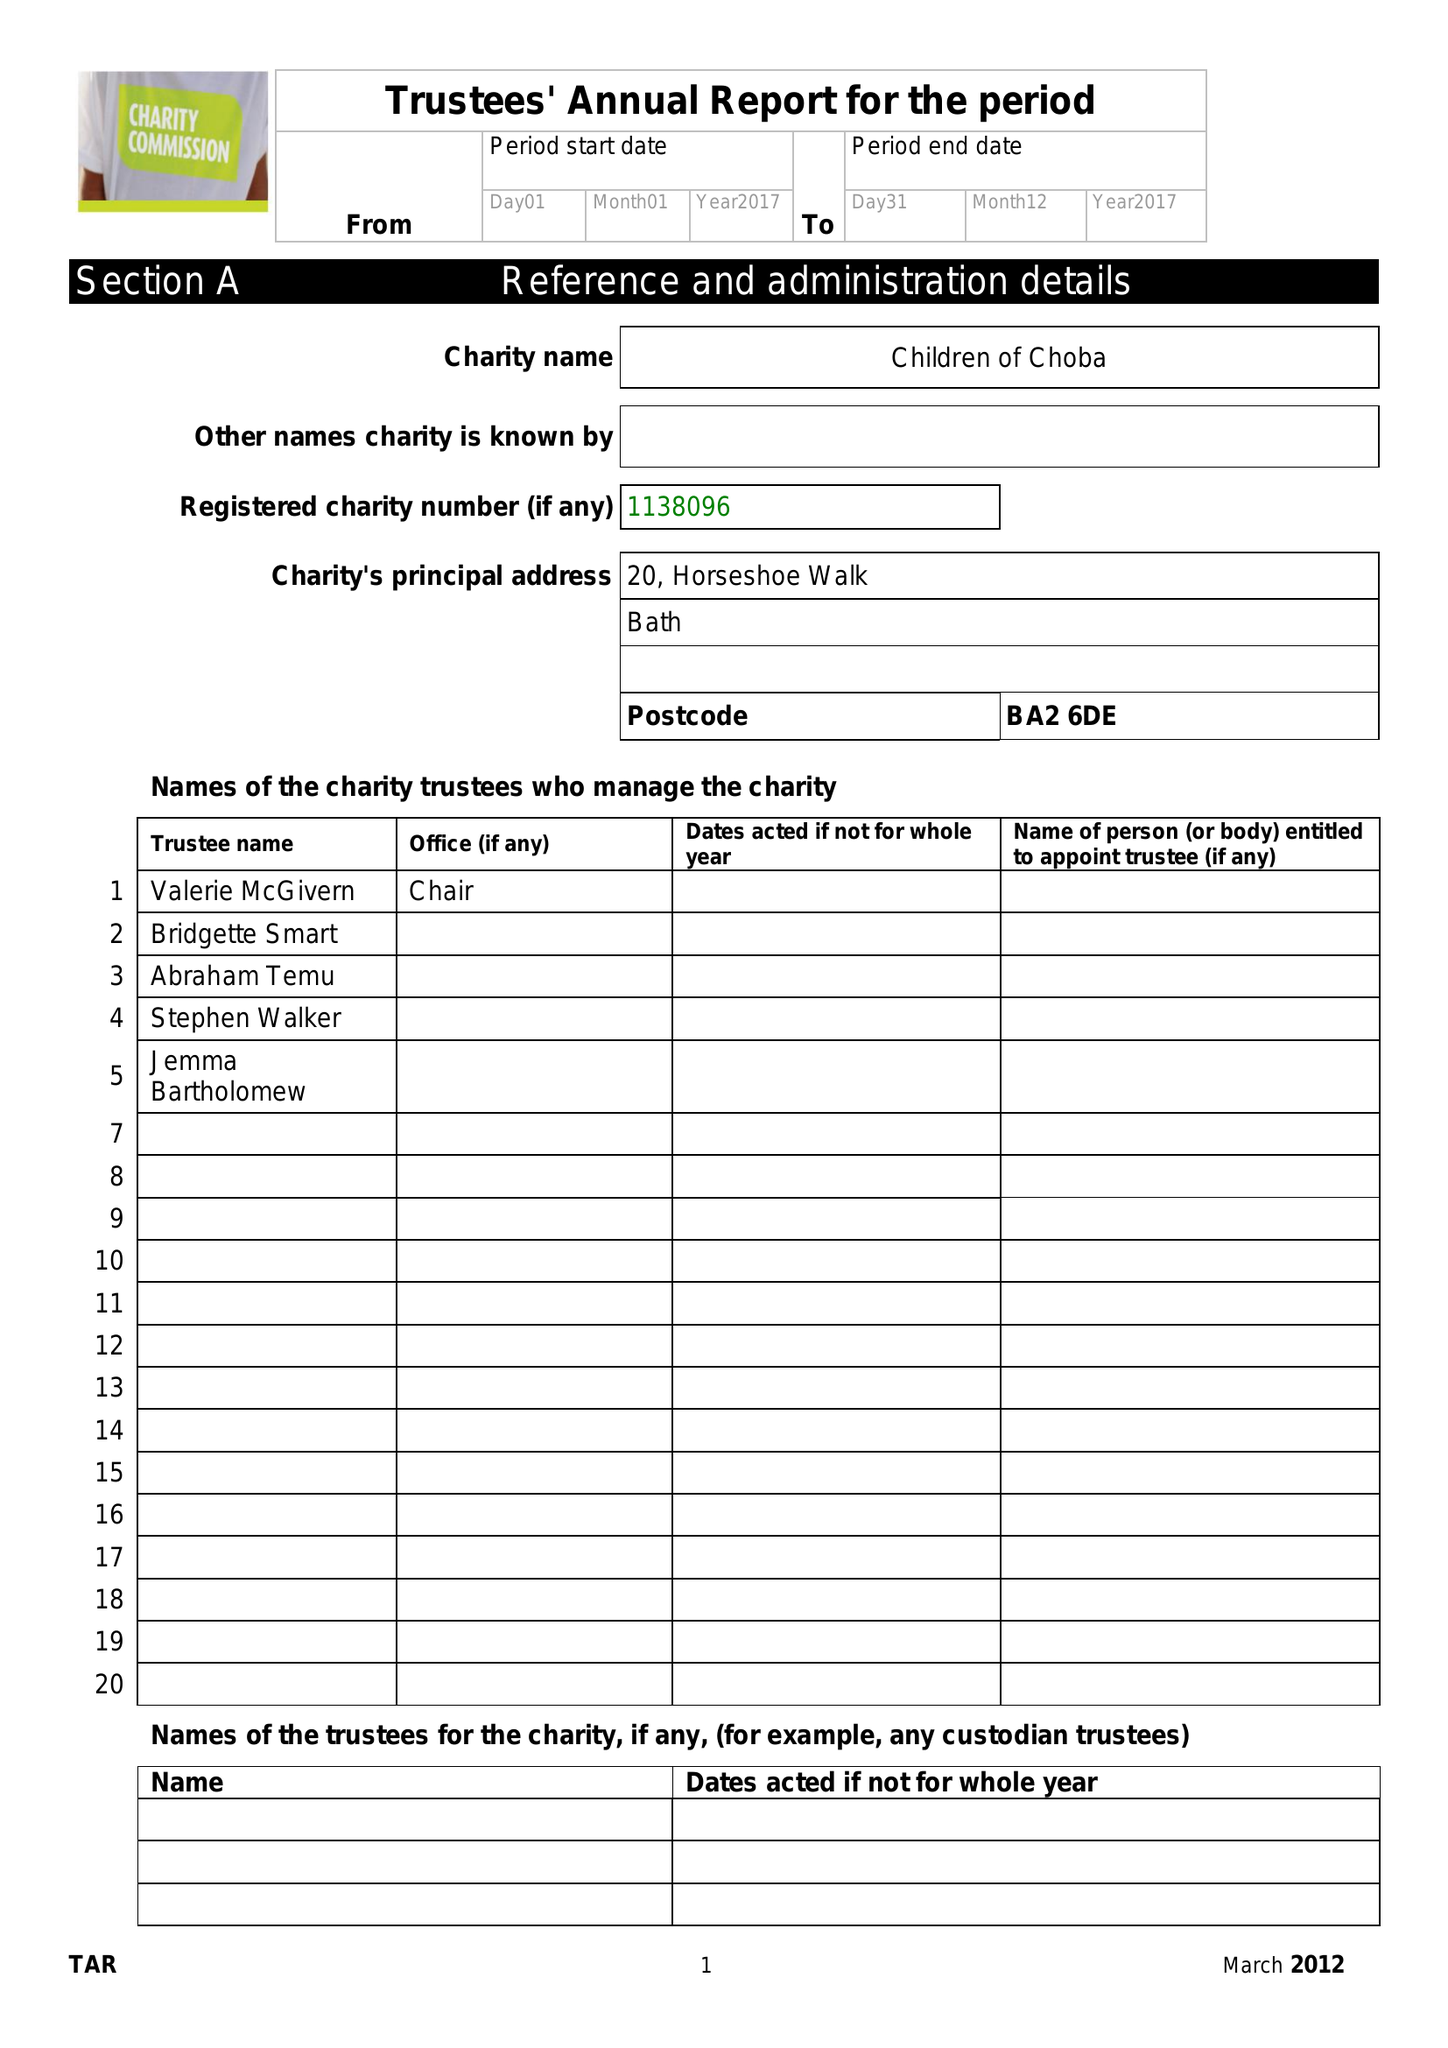What is the value for the report_date?
Answer the question using a single word or phrase. 2017-12-31 